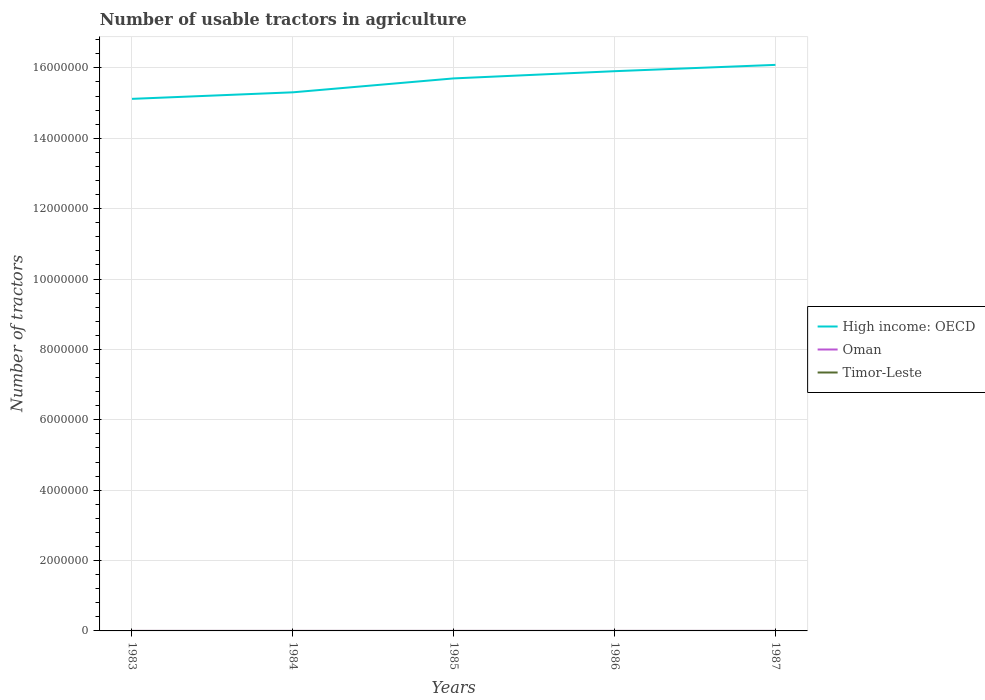Does the line corresponding to Oman intersect with the line corresponding to Timor-Leste?
Your answer should be very brief. No. Is the number of lines equal to the number of legend labels?
Offer a terse response. Yes. Across all years, what is the maximum number of usable tractors in agriculture in High income: OECD?
Give a very brief answer. 1.51e+07. In which year was the number of usable tractors in agriculture in Oman maximum?
Ensure brevity in your answer.  1983. What is the total number of usable tractors in agriculture in Timor-Leste in the graph?
Provide a succinct answer. 0. What is the difference between the highest and the second highest number of usable tractors in agriculture in High income: OECD?
Offer a terse response. 9.65e+05. What is the difference between the highest and the lowest number of usable tractors in agriculture in Timor-Leste?
Keep it short and to the point. 0. How many lines are there?
Offer a very short reply. 3. How many years are there in the graph?
Your answer should be compact. 5. Are the values on the major ticks of Y-axis written in scientific E-notation?
Ensure brevity in your answer.  No. Does the graph contain any zero values?
Offer a very short reply. No. Where does the legend appear in the graph?
Offer a very short reply. Center right. What is the title of the graph?
Provide a succinct answer. Number of usable tractors in agriculture. Does "Ghana" appear as one of the legend labels in the graph?
Provide a succinct answer. No. What is the label or title of the X-axis?
Your answer should be very brief. Years. What is the label or title of the Y-axis?
Your answer should be very brief. Number of tractors. What is the Number of tractors of High income: OECD in 1983?
Make the answer very short. 1.51e+07. What is the Number of tractors in Oman in 1983?
Offer a terse response. 102. What is the Number of tractors of Timor-Leste in 1983?
Give a very brief answer. 95. What is the Number of tractors of High income: OECD in 1984?
Your answer should be very brief. 1.53e+07. What is the Number of tractors of Oman in 1984?
Offer a terse response. 103. What is the Number of tractors in High income: OECD in 1985?
Make the answer very short. 1.57e+07. What is the Number of tractors in Oman in 1985?
Make the answer very short. 125. What is the Number of tractors in High income: OECD in 1986?
Offer a terse response. 1.59e+07. What is the Number of tractors in Oman in 1986?
Your response must be concise. 125. What is the Number of tractors in Timor-Leste in 1986?
Your response must be concise. 95. What is the Number of tractors of High income: OECD in 1987?
Provide a succinct answer. 1.61e+07. What is the Number of tractors in Oman in 1987?
Provide a short and direct response. 130. Across all years, what is the maximum Number of tractors in High income: OECD?
Make the answer very short. 1.61e+07. Across all years, what is the maximum Number of tractors in Oman?
Ensure brevity in your answer.  130. Across all years, what is the maximum Number of tractors of Timor-Leste?
Provide a succinct answer. 95. Across all years, what is the minimum Number of tractors of High income: OECD?
Provide a short and direct response. 1.51e+07. Across all years, what is the minimum Number of tractors in Oman?
Offer a terse response. 102. Across all years, what is the minimum Number of tractors of Timor-Leste?
Keep it short and to the point. 95. What is the total Number of tractors in High income: OECD in the graph?
Offer a very short reply. 7.81e+07. What is the total Number of tractors of Oman in the graph?
Provide a short and direct response. 585. What is the total Number of tractors in Timor-Leste in the graph?
Provide a succinct answer. 475. What is the difference between the Number of tractors of High income: OECD in 1983 and that in 1984?
Keep it short and to the point. -1.86e+05. What is the difference between the Number of tractors in Timor-Leste in 1983 and that in 1984?
Your answer should be compact. 0. What is the difference between the Number of tractors of High income: OECD in 1983 and that in 1985?
Offer a terse response. -5.81e+05. What is the difference between the Number of tractors in Oman in 1983 and that in 1985?
Your response must be concise. -23. What is the difference between the Number of tractors of High income: OECD in 1983 and that in 1986?
Make the answer very short. -7.86e+05. What is the difference between the Number of tractors in High income: OECD in 1983 and that in 1987?
Provide a short and direct response. -9.65e+05. What is the difference between the Number of tractors of Timor-Leste in 1983 and that in 1987?
Provide a short and direct response. 0. What is the difference between the Number of tractors in High income: OECD in 1984 and that in 1985?
Your response must be concise. -3.95e+05. What is the difference between the Number of tractors of Timor-Leste in 1984 and that in 1985?
Ensure brevity in your answer.  0. What is the difference between the Number of tractors in High income: OECD in 1984 and that in 1986?
Ensure brevity in your answer.  -6.01e+05. What is the difference between the Number of tractors in Timor-Leste in 1984 and that in 1986?
Provide a short and direct response. 0. What is the difference between the Number of tractors in High income: OECD in 1984 and that in 1987?
Give a very brief answer. -7.80e+05. What is the difference between the Number of tractors of Oman in 1984 and that in 1987?
Keep it short and to the point. -27. What is the difference between the Number of tractors of Timor-Leste in 1984 and that in 1987?
Ensure brevity in your answer.  0. What is the difference between the Number of tractors in High income: OECD in 1985 and that in 1986?
Your response must be concise. -2.05e+05. What is the difference between the Number of tractors in Timor-Leste in 1985 and that in 1986?
Your answer should be compact. 0. What is the difference between the Number of tractors in High income: OECD in 1985 and that in 1987?
Keep it short and to the point. -3.84e+05. What is the difference between the Number of tractors in Timor-Leste in 1985 and that in 1987?
Provide a succinct answer. 0. What is the difference between the Number of tractors of High income: OECD in 1986 and that in 1987?
Make the answer very short. -1.79e+05. What is the difference between the Number of tractors of Oman in 1986 and that in 1987?
Provide a short and direct response. -5. What is the difference between the Number of tractors of High income: OECD in 1983 and the Number of tractors of Oman in 1984?
Provide a succinct answer. 1.51e+07. What is the difference between the Number of tractors of High income: OECD in 1983 and the Number of tractors of Timor-Leste in 1984?
Make the answer very short. 1.51e+07. What is the difference between the Number of tractors in Oman in 1983 and the Number of tractors in Timor-Leste in 1984?
Give a very brief answer. 7. What is the difference between the Number of tractors in High income: OECD in 1983 and the Number of tractors in Oman in 1985?
Your answer should be compact. 1.51e+07. What is the difference between the Number of tractors in High income: OECD in 1983 and the Number of tractors in Timor-Leste in 1985?
Offer a very short reply. 1.51e+07. What is the difference between the Number of tractors in High income: OECD in 1983 and the Number of tractors in Oman in 1986?
Keep it short and to the point. 1.51e+07. What is the difference between the Number of tractors in High income: OECD in 1983 and the Number of tractors in Timor-Leste in 1986?
Your answer should be compact. 1.51e+07. What is the difference between the Number of tractors in Oman in 1983 and the Number of tractors in Timor-Leste in 1986?
Offer a very short reply. 7. What is the difference between the Number of tractors of High income: OECD in 1983 and the Number of tractors of Oman in 1987?
Your answer should be compact. 1.51e+07. What is the difference between the Number of tractors in High income: OECD in 1983 and the Number of tractors in Timor-Leste in 1987?
Give a very brief answer. 1.51e+07. What is the difference between the Number of tractors of Oman in 1983 and the Number of tractors of Timor-Leste in 1987?
Keep it short and to the point. 7. What is the difference between the Number of tractors in High income: OECD in 1984 and the Number of tractors in Oman in 1985?
Make the answer very short. 1.53e+07. What is the difference between the Number of tractors of High income: OECD in 1984 and the Number of tractors of Timor-Leste in 1985?
Provide a succinct answer. 1.53e+07. What is the difference between the Number of tractors in Oman in 1984 and the Number of tractors in Timor-Leste in 1985?
Keep it short and to the point. 8. What is the difference between the Number of tractors in High income: OECD in 1984 and the Number of tractors in Oman in 1986?
Your response must be concise. 1.53e+07. What is the difference between the Number of tractors in High income: OECD in 1984 and the Number of tractors in Timor-Leste in 1986?
Provide a short and direct response. 1.53e+07. What is the difference between the Number of tractors in High income: OECD in 1984 and the Number of tractors in Oman in 1987?
Ensure brevity in your answer.  1.53e+07. What is the difference between the Number of tractors in High income: OECD in 1984 and the Number of tractors in Timor-Leste in 1987?
Give a very brief answer. 1.53e+07. What is the difference between the Number of tractors in Oman in 1984 and the Number of tractors in Timor-Leste in 1987?
Provide a succinct answer. 8. What is the difference between the Number of tractors of High income: OECD in 1985 and the Number of tractors of Oman in 1986?
Keep it short and to the point. 1.57e+07. What is the difference between the Number of tractors in High income: OECD in 1985 and the Number of tractors in Timor-Leste in 1986?
Your answer should be compact. 1.57e+07. What is the difference between the Number of tractors in High income: OECD in 1985 and the Number of tractors in Oman in 1987?
Ensure brevity in your answer.  1.57e+07. What is the difference between the Number of tractors in High income: OECD in 1985 and the Number of tractors in Timor-Leste in 1987?
Offer a terse response. 1.57e+07. What is the difference between the Number of tractors of High income: OECD in 1986 and the Number of tractors of Oman in 1987?
Provide a succinct answer. 1.59e+07. What is the difference between the Number of tractors of High income: OECD in 1986 and the Number of tractors of Timor-Leste in 1987?
Make the answer very short. 1.59e+07. What is the average Number of tractors in High income: OECD per year?
Give a very brief answer. 1.56e+07. What is the average Number of tractors in Oman per year?
Ensure brevity in your answer.  117. In the year 1983, what is the difference between the Number of tractors in High income: OECD and Number of tractors in Oman?
Give a very brief answer. 1.51e+07. In the year 1983, what is the difference between the Number of tractors of High income: OECD and Number of tractors of Timor-Leste?
Offer a very short reply. 1.51e+07. In the year 1983, what is the difference between the Number of tractors in Oman and Number of tractors in Timor-Leste?
Provide a short and direct response. 7. In the year 1984, what is the difference between the Number of tractors of High income: OECD and Number of tractors of Oman?
Provide a short and direct response. 1.53e+07. In the year 1984, what is the difference between the Number of tractors of High income: OECD and Number of tractors of Timor-Leste?
Ensure brevity in your answer.  1.53e+07. In the year 1984, what is the difference between the Number of tractors in Oman and Number of tractors in Timor-Leste?
Ensure brevity in your answer.  8. In the year 1985, what is the difference between the Number of tractors of High income: OECD and Number of tractors of Oman?
Give a very brief answer. 1.57e+07. In the year 1985, what is the difference between the Number of tractors in High income: OECD and Number of tractors in Timor-Leste?
Ensure brevity in your answer.  1.57e+07. In the year 1985, what is the difference between the Number of tractors of Oman and Number of tractors of Timor-Leste?
Your answer should be very brief. 30. In the year 1986, what is the difference between the Number of tractors in High income: OECD and Number of tractors in Oman?
Offer a very short reply. 1.59e+07. In the year 1986, what is the difference between the Number of tractors in High income: OECD and Number of tractors in Timor-Leste?
Offer a terse response. 1.59e+07. In the year 1986, what is the difference between the Number of tractors of Oman and Number of tractors of Timor-Leste?
Ensure brevity in your answer.  30. In the year 1987, what is the difference between the Number of tractors in High income: OECD and Number of tractors in Oman?
Offer a terse response. 1.61e+07. In the year 1987, what is the difference between the Number of tractors in High income: OECD and Number of tractors in Timor-Leste?
Your answer should be compact. 1.61e+07. In the year 1987, what is the difference between the Number of tractors of Oman and Number of tractors of Timor-Leste?
Your response must be concise. 35. What is the ratio of the Number of tractors in High income: OECD in 1983 to that in 1984?
Give a very brief answer. 0.99. What is the ratio of the Number of tractors in Oman in 1983 to that in 1984?
Your answer should be very brief. 0.99. What is the ratio of the Number of tractors of High income: OECD in 1983 to that in 1985?
Offer a very short reply. 0.96. What is the ratio of the Number of tractors in Oman in 1983 to that in 1985?
Make the answer very short. 0.82. What is the ratio of the Number of tractors of High income: OECD in 1983 to that in 1986?
Offer a terse response. 0.95. What is the ratio of the Number of tractors in Oman in 1983 to that in 1986?
Keep it short and to the point. 0.82. What is the ratio of the Number of tractors in Timor-Leste in 1983 to that in 1986?
Offer a terse response. 1. What is the ratio of the Number of tractors in Oman in 1983 to that in 1987?
Your answer should be very brief. 0.78. What is the ratio of the Number of tractors in Timor-Leste in 1983 to that in 1987?
Provide a short and direct response. 1. What is the ratio of the Number of tractors of High income: OECD in 1984 to that in 1985?
Your answer should be compact. 0.97. What is the ratio of the Number of tractors of Oman in 1984 to that in 1985?
Provide a short and direct response. 0.82. What is the ratio of the Number of tractors in High income: OECD in 1984 to that in 1986?
Provide a succinct answer. 0.96. What is the ratio of the Number of tractors of Oman in 1984 to that in 1986?
Provide a succinct answer. 0.82. What is the ratio of the Number of tractors in High income: OECD in 1984 to that in 1987?
Keep it short and to the point. 0.95. What is the ratio of the Number of tractors in Oman in 1984 to that in 1987?
Give a very brief answer. 0.79. What is the ratio of the Number of tractors in Timor-Leste in 1984 to that in 1987?
Make the answer very short. 1. What is the ratio of the Number of tractors in High income: OECD in 1985 to that in 1986?
Offer a terse response. 0.99. What is the ratio of the Number of tractors in Oman in 1985 to that in 1986?
Give a very brief answer. 1. What is the ratio of the Number of tractors of High income: OECD in 1985 to that in 1987?
Keep it short and to the point. 0.98. What is the ratio of the Number of tractors in Oman in 1985 to that in 1987?
Ensure brevity in your answer.  0.96. What is the ratio of the Number of tractors of Timor-Leste in 1985 to that in 1987?
Your answer should be very brief. 1. What is the ratio of the Number of tractors of High income: OECD in 1986 to that in 1987?
Make the answer very short. 0.99. What is the ratio of the Number of tractors in Oman in 1986 to that in 1987?
Offer a very short reply. 0.96. What is the difference between the highest and the second highest Number of tractors of High income: OECD?
Your response must be concise. 1.79e+05. What is the difference between the highest and the lowest Number of tractors of High income: OECD?
Ensure brevity in your answer.  9.65e+05. What is the difference between the highest and the lowest Number of tractors in Oman?
Offer a terse response. 28. 